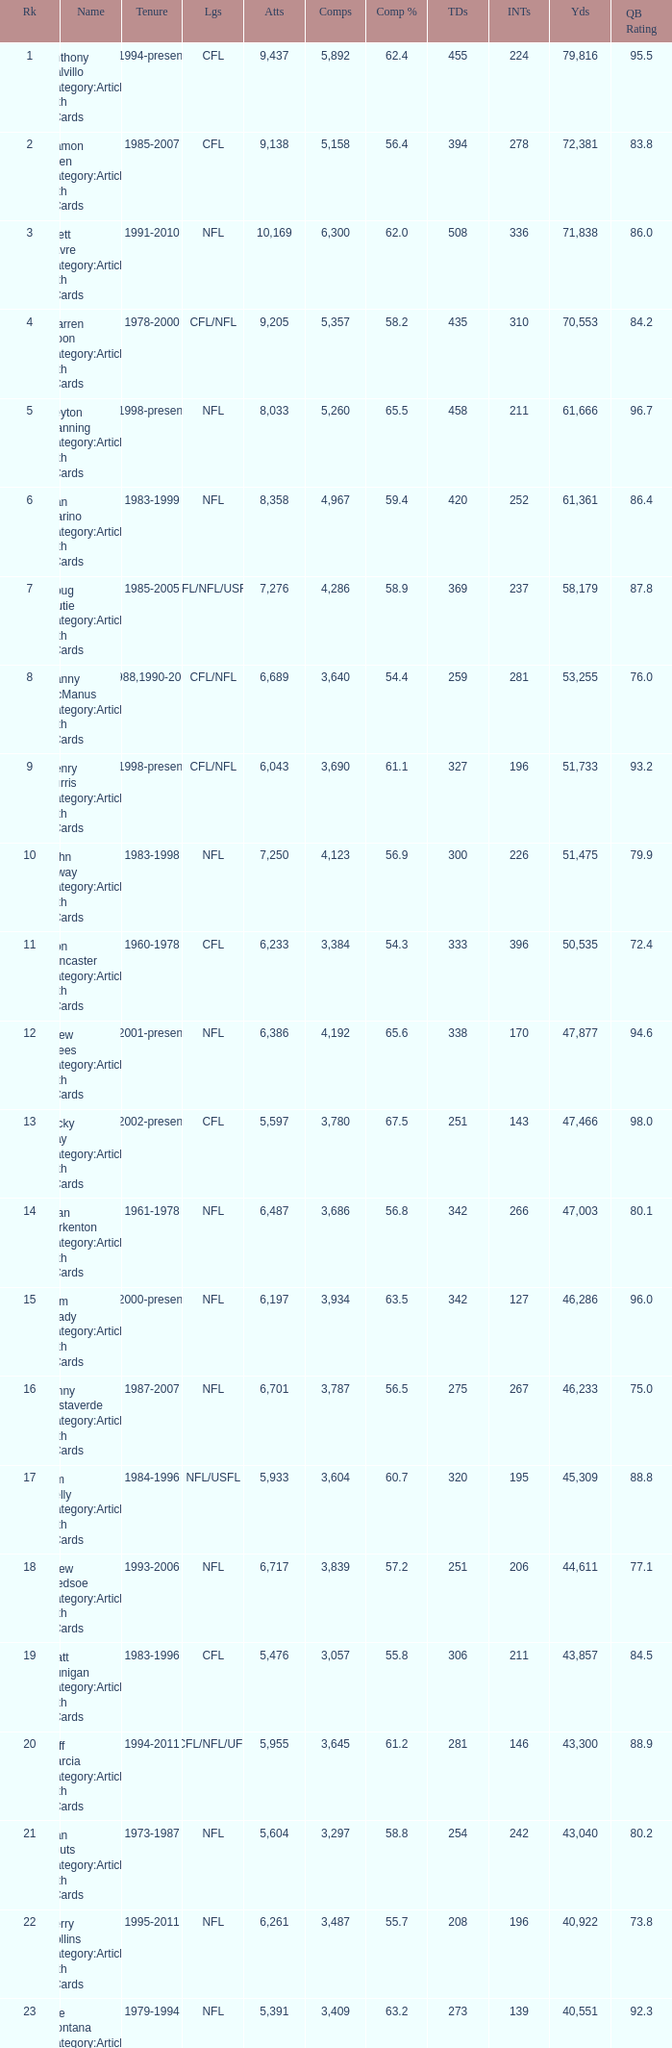What is the number of interceptions with less than 3,487 completions , more than 40,551 yardage, and the comp % is 55.8? 211.0. 